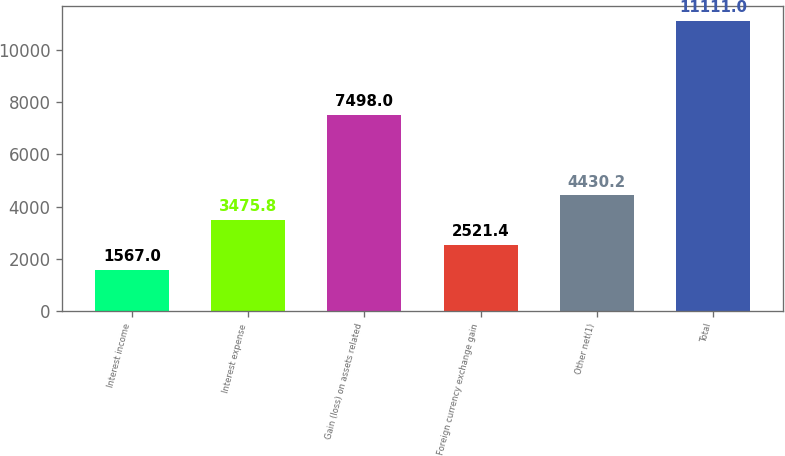Convert chart. <chart><loc_0><loc_0><loc_500><loc_500><bar_chart><fcel>Interest income<fcel>Interest expense<fcel>Gain (loss) on assets related<fcel>Foreign currency exchange gain<fcel>Other net(1)<fcel>Total<nl><fcel>1567<fcel>3475.8<fcel>7498<fcel>2521.4<fcel>4430.2<fcel>11111<nl></chart> 